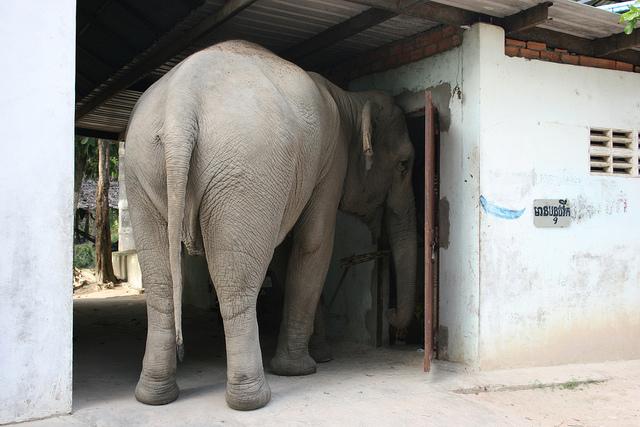Will he fit in the door?
Give a very brief answer. No. Is the elephant going to get hurt?
Keep it brief. No. Is there blue in this photo?
Be succinct. Yes. Is the elephant looking for food?
Be succinct. Yes. 